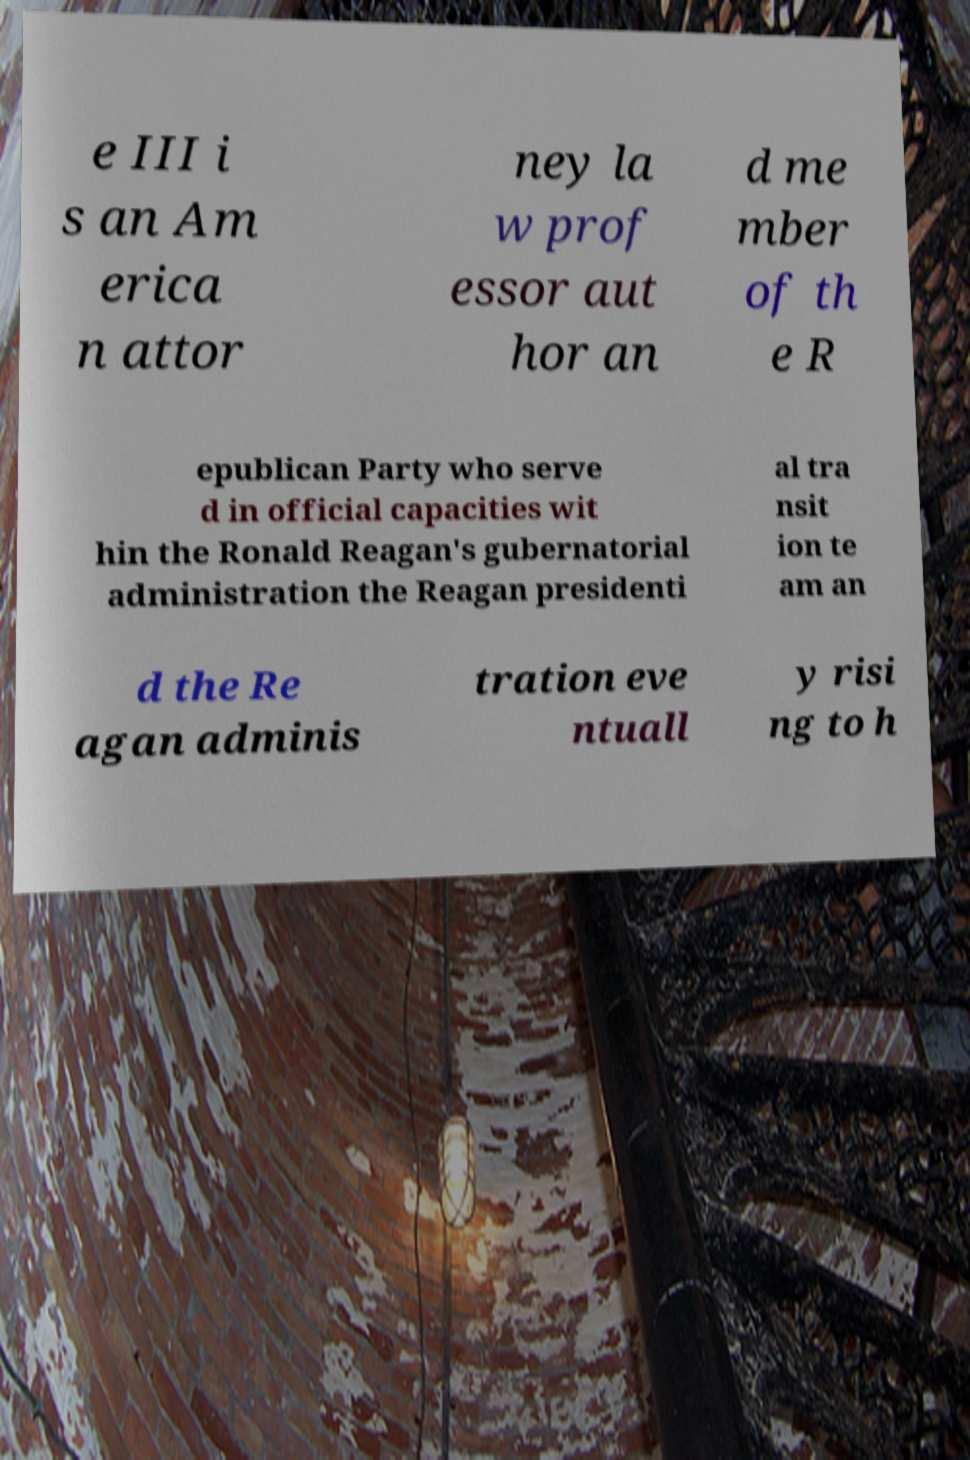Can you accurately transcribe the text from the provided image for me? e III i s an Am erica n attor ney la w prof essor aut hor an d me mber of th e R epublican Party who serve d in official capacities wit hin the Ronald Reagan's gubernatorial administration the Reagan presidenti al tra nsit ion te am an d the Re agan adminis tration eve ntuall y risi ng to h 